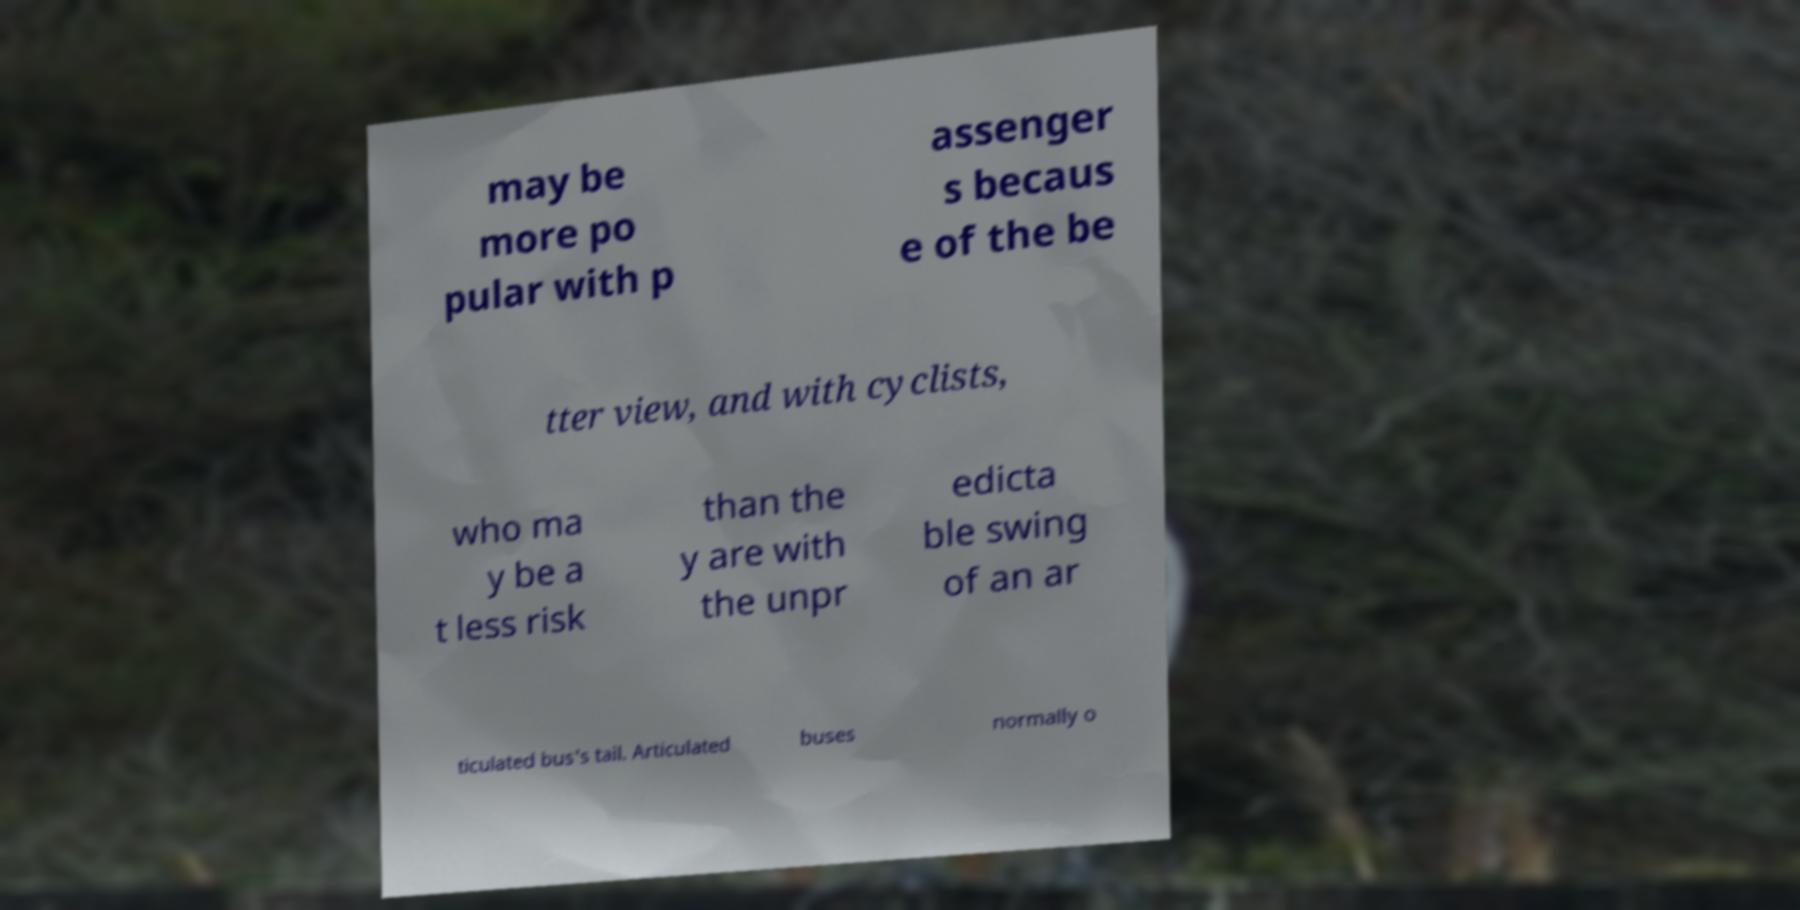Can you read and provide the text displayed in the image?This photo seems to have some interesting text. Can you extract and type it out for me? may be more po pular with p assenger s becaus e of the be tter view, and with cyclists, who ma y be a t less risk than the y are with the unpr edicta ble swing of an ar ticulated bus's tail. Articulated buses normally o 